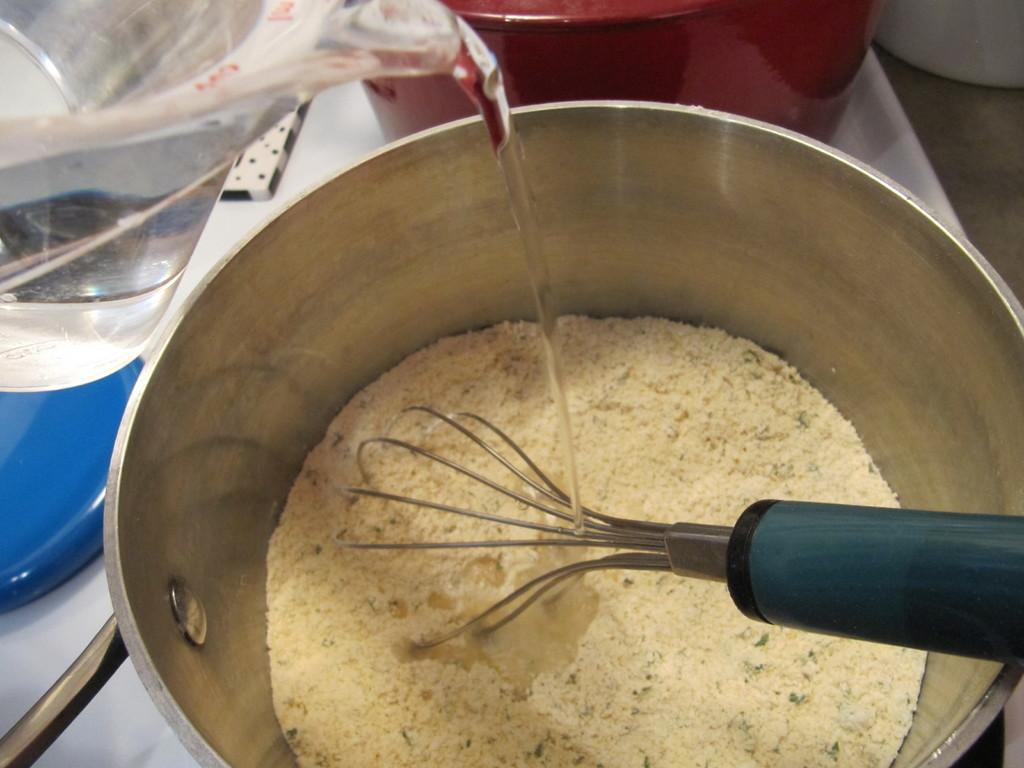Describe this image in one or two sentences. In this image I can see in a steel vessel, there is a powder and a stirrer. On the left side there is a water jug, the water is flowing from jug to this vessel. 